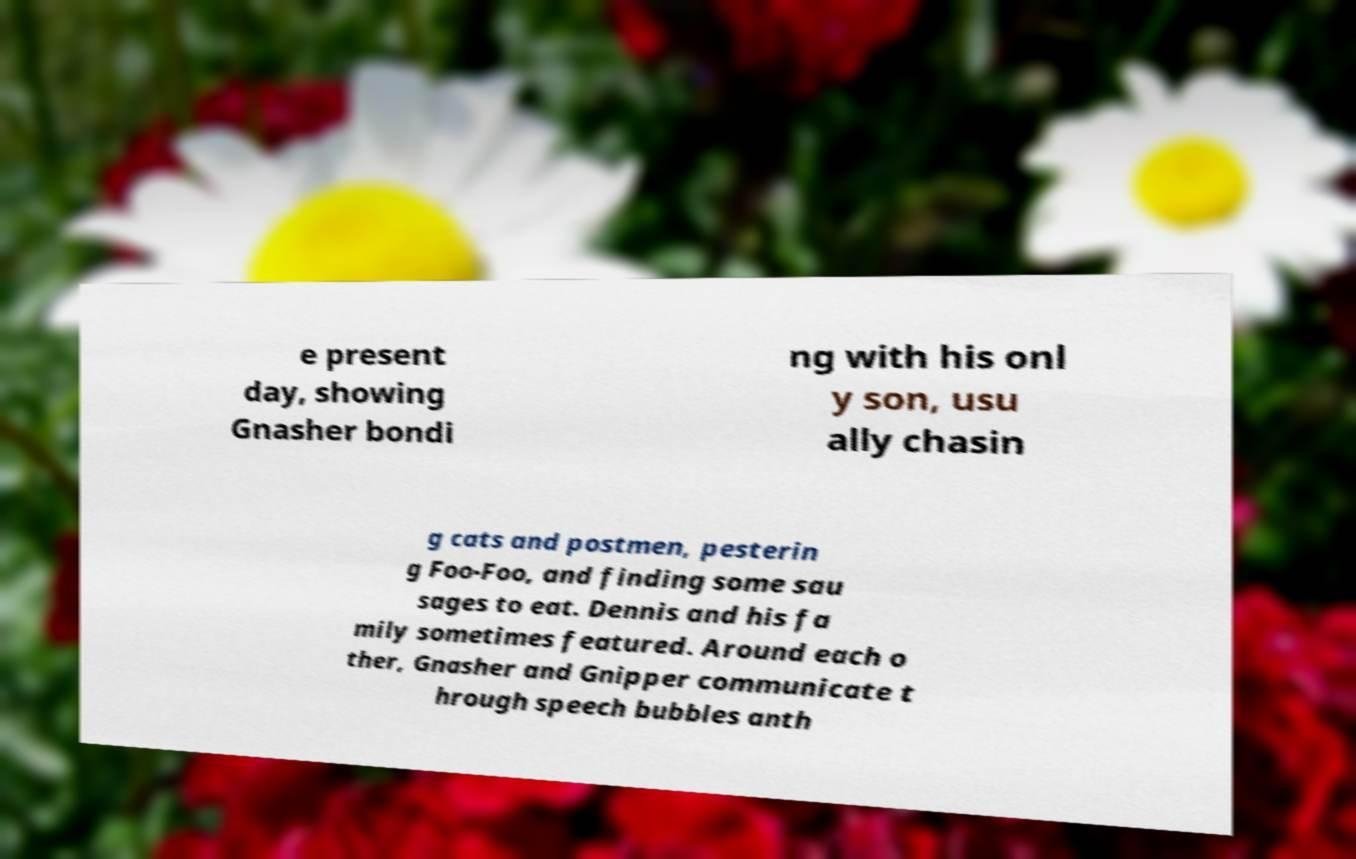I need the written content from this picture converted into text. Can you do that? e present day, showing Gnasher bondi ng with his onl y son, usu ally chasin g cats and postmen, pesterin g Foo-Foo, and finding some sau sages to eat. Dennis and his fa mily sometimes featured. Around each o ther, Gnasher and Gnipper communicate t hrough speech bubbles anth 